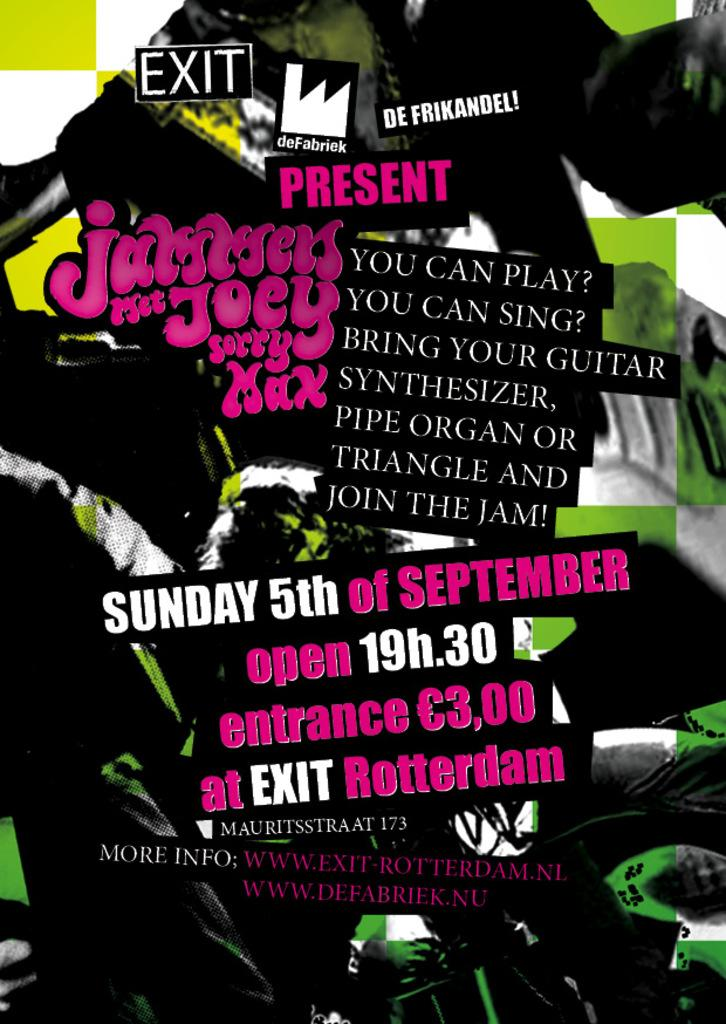What type of picture is in the image? The image contains an edited picture. What can be seen in the edited picture? There is a woman standing in the edited picture. Are there any words or phrases in the edited picture? Yes, there is text present in the edited picture. What type of beast can be seen attacking the woman in the image? There is no beast present in the image; it contains an edited picture of a woman standing with text. 